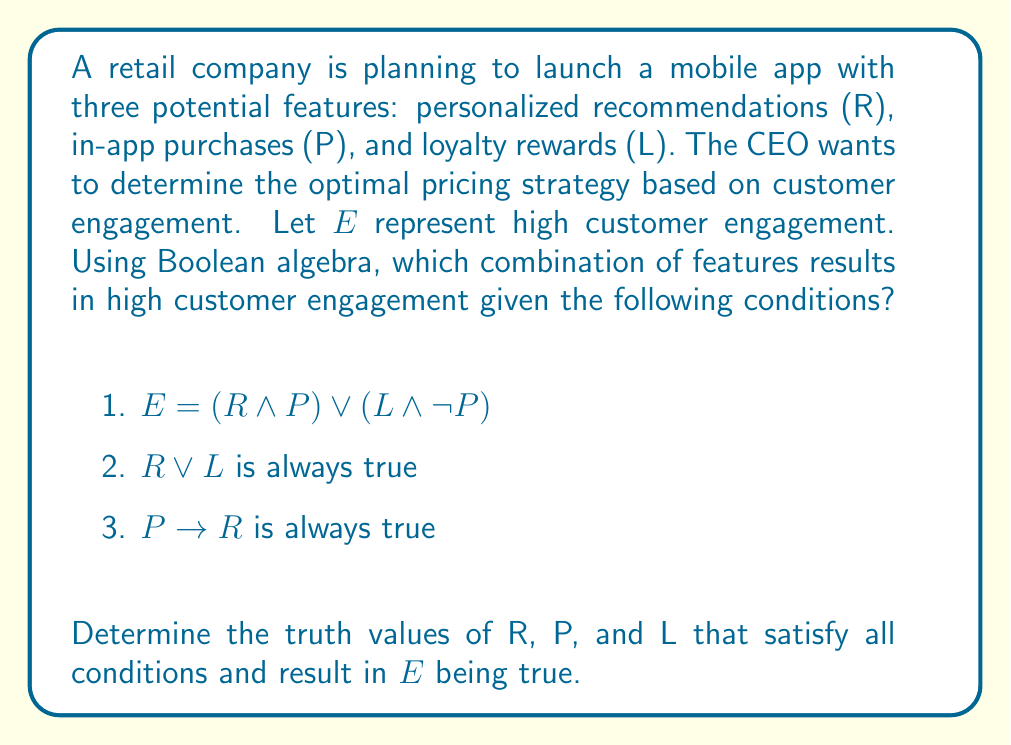Show me your answer to this math problem. Let's approach this step-by-step using Boolean algebra:

1) First, we need to consider the given conditions:
   
   a) $E = (R \land P) \lor (L \land \neg P)$
   b) $R \lor L$ is always true
   c) $P \rightarrow R$ is always true

2) From condition (b), we know that either R or L (or both) must be true.

3) From condition (c), we know that if P is true, R must also be true. This can be written as $\neg P \lor R$.

4) Now, let's consider the possible combinations of R, P, and L:

   $$\begin{array}{|c|c|c|c|}
   \hline
   R & P & L & E \\
   \hline
   1 & 0 & 1 & 1 \\
   1 & 1 & 0 & 1 \\
   1 & 1 & 1 & 1 \\
   1 & 0 & 0 & 0 \\
   0 & 0 & 1 & 1 \\
   \hline
   \end{array}$$

   Note: The combination (0, 1, 0) and (0, 1, 1) are not possible due to condition (c).

5) From this truth table, we can see that there are three combinations that satisfy all conditions and result in E being true:
   
   - R = 1, P = 0, L = 1
   - R = 1, P = 1, L = 0
   - R = 1, P = 1, L = 1

6) These combinations represent the optimal feature sets for high customer engagement.
Answer: (R = 1, P = 0, L = 1), (R = 1, P = 1, L = 0), or (R = 1, P = 1, L = 1) 